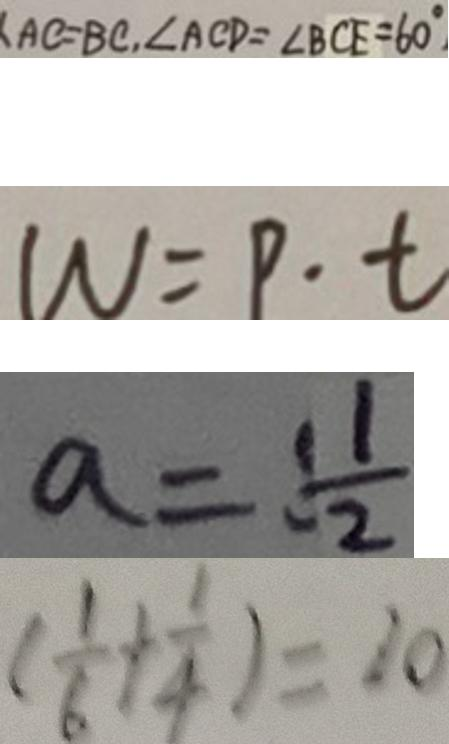<formula> <loc_0><loc_0><loc_500><loc_500>A C = B C , \angle A C D = \angle B C E = 6 0 ^ { \circ } 
 W = p \cdot t 
 a = \frac { 1 1 } { 2 } 
 ( \frac { 1 } { 6 } + \frac { 1 } { 4 } ) = 2 0</formula> 